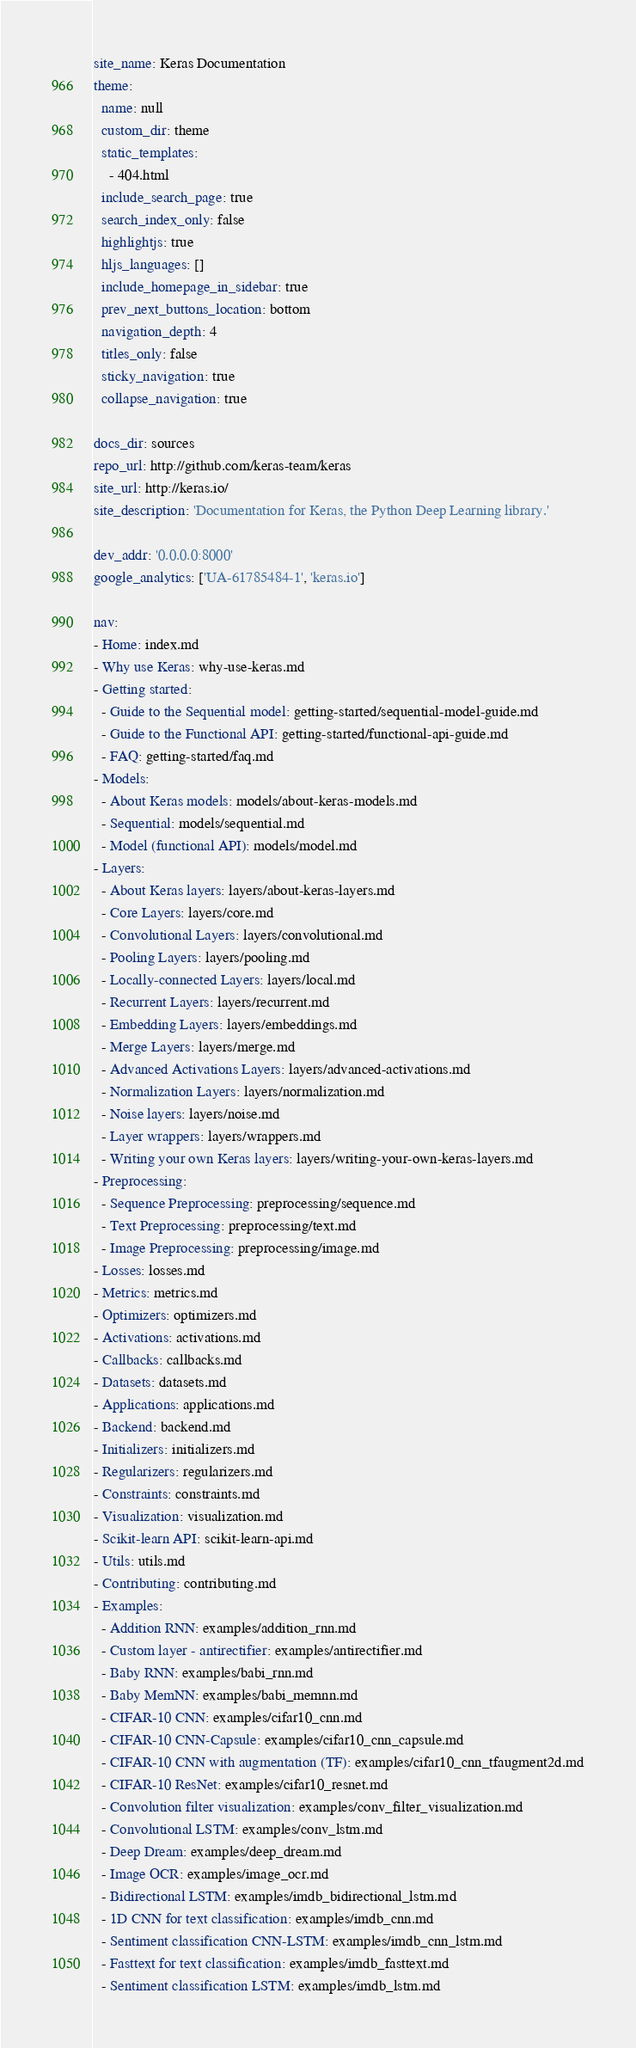Convert code to text. <code><loc_0><loc_0><loc_500><loc_500><_YAML_>site_name: Keras Documentation
theme:
  name: null
  custom_dir: theme
  static_templates:
    - 404.html
  include_search_page: true
  search_index_only: false
  highlightjs: true
  hljs_languages: []
  include_homepage_in_sidebar: true
  prev_next_buttons_location: bottom
  navigation_depth: 4
  titles_only: false
  sticky_navigation: true
  collapse_navigation: true

docs_dir: sources
repo_url: http://github.com/keras-team/keras
site_url: http://keras.io/
site_description: 'Documentation for Keras, the Python Deep Learning library.'

dev_addr: '0.0.0.0:8000'
google_analytics: ['UA-61785484-1', 'keras.io']

nav:
- Home: index.md
- Why use Keras: why-use-keras.md
- Getting started:
  - Guide to the Sequential model: getting-started/sequential-model-guide.md
  - Guide to the Functional API: getting-started/functional-api-guide.md
  - FAQ: getting-started/faq.md
- Models:
  - About Keras models: models/about-keras-models.md
  - Sequential: models/sequential.md
  - Model (functional API): models/model.md
- Layers:
  - About Keras layers: layers/about-keras-layers.md
  - Core Layers: layers/core.md
  - Convolutional Layers: layers/convolutional.md
  - Pooling Layers: layers/pooling.md
  - Locally-connected Layers: layers/local.md
  - Recurrent Layers: layers/recurrent.md
  - Embedding Layers: layers/embeddings.md
  - Merge Layers: layers/merge.md
  - Advanced Activations Layers: layers/advanced-activations.md
  - Normalization Layers: layers/normalization.md
  - Noise layers: layers/noise.md
  - Layer wrappers: layers/wrappers.md
  - Writing your own Keras layers: layers/writing-your-own-keras-layers.md
- Preprocessing:
  - Sequence Preprocessing: preprocessing/sequence.md
  - Text Preprocessing: preprocessing/text.md
  - Image Preprocessing: preprocessing/image.md
- Losses: losses.md
- Metrics: metrics.md
- Optimizers: optimizers.md
- Activations: activations.md
- Callbacks: callbacks.md
- Datasets: datasets.md
- Applications: applications.md
- Backend: backend.md
- Initializers: initializers.md
- Regularizers: regularizers.md
- Constraints: constraints.md
- Visualization: visualization.md
- Scikit-learn API: scikit-learn-api.md
- Utils: utils.md
- Contributing: contributing.md
- Examples:
  - Addition RNN: examples/addition_rnn.md
  - Custom layer - antirectifier: examples/antirectifier.md
  - Baby RNN: examples/babi_rnn.md
  - Baby MemNN: examples/babi_memnn.md
  - CIFAR-10 CNN: examples/cifar10_cnn.md
  - CIFAR-10 CNN-Capsule: examples/cifar10_cnn_capsule.md
  - CIFAR-10 CNN with augmentation (TF): examples/cifar10_cnn_tfaugment2d.md
  - CIFAR-10 ResNet: examples/cifar10_resnet.md
  - Convolution filter visualization: examples/conv_filter_visualization.md
  - Convolutional LSTM: examples/conv_lstm.md
  - Deep Dream: examples/deep_dream.md
  - Image OCR: examples/image_ocr.md
  - Bidirectional LSTM: examples/imdb_bidirectional_lstm.md
  - 1D CNN for text classification: examples/imdb_cnn.md
  - Sentiment classification CNN-LSTM: examples/imdb_cnn_lstm.md
  - Fasttext for text classification: examples/imdb_fasttext.md
  - Sentiment classification LSTM: examples/imdb_lstm.md
</code> 